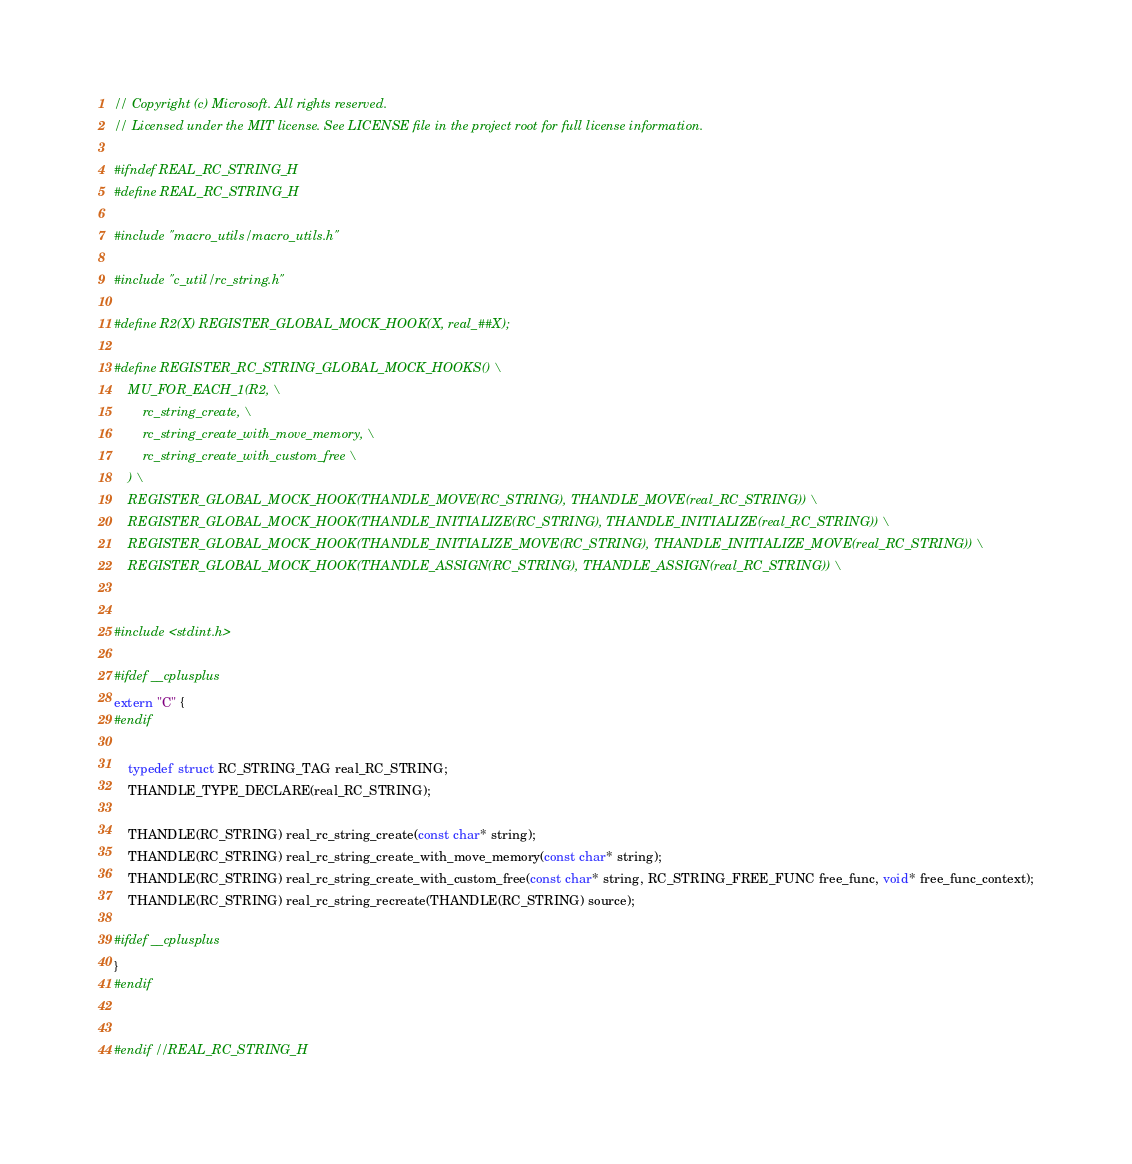<code> <loc_0><loc_0><loc_500><loc_500><_C_>// Copyright (c) Microsoft. All rights reserved.
// Licensed under the MIT license. See LICENSE file in the project root for full license information.

#ifndef REAL_RC_STRING_H
#define REAL_RC_STRING_H

#include "macro_utils/macro_utils.h"

#include "c_util/rc_string.h"

#define R2(X) REGISTER_GLOBAL_MOCK_HOOK(X, real_##X);

#define REGISTER_RC_STRING_GLOBAL_MOCK_HOOKS() \
    MU_FOR_EACH_1(R2, \
        rc_string_create, \
        rc_string_create_with_move_memory, \
        rc_string_create_with_custom_free \
    ) \
    REGISTER_GLOBAL_MOCK_HOOK(THANDLE_MOVE(RC_STRING), THANDLE_MOVE(real_RC_STRING)) \
    REGISTER_GLOBAL_MOCK_HOOK(THANDLE_INITIALIZE(RC_STRING), THANDLE_INITIALIZE(real_RC_STRING)) \
    REGISTER_GLOBAL_MOCK_HOOK(THANDLE_INITIALIZE_MOVE(RC_STRING), THANDLE_INITIALIZE_MOVE(real_RC_STRING)) \
    REGISTER_GLOBAL_MOCK_HOOK(THANDLE_ASSIGN(RC_STRING), THANDLE_ASSIGN(real_RC_STRING)) \


#include <stdint.h>

#ifdef __cplusplus
extern "C" {
#endif

    typedef struct RC_STRING_TAG real_RC_STRING;
    THANDLE_TYPE_DECLARE(real_RC_STRING);

    THANDLE(RC_STRING) real_rc_string_create(const char* string);
    THANDLE(RC_STRING) real_rc_string_create_with_move_memory(const char* string);
    THANDLE(RC_STRING) real_rc_string_create_with_custom_free(const char* string, RC_STRING_FREE_FUNC free_func, void* free_func_context);
    THANDLE(RC_STRING) real_rc_string_recreate(THANDLE(RC_STRING) source);

#ifdef __cplusplus
}
#endif


#endif //REAL_RC_STRING_H
</code> 